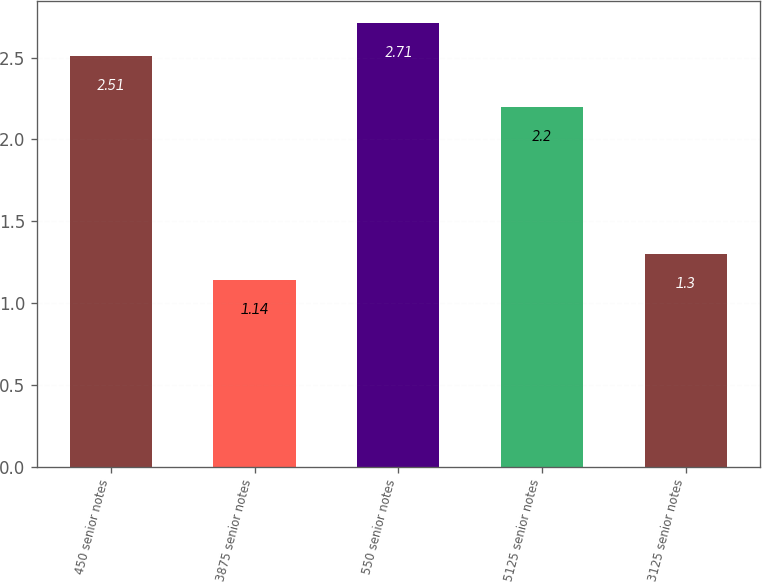Convert chart to OTSL. <chart><loc_0><loc_0><loc_500><loc_500><bar_chart><fcel>450 senior notes<fcel>3875 senior notes<fcel>550 senior notes<fcel>5125 senior notes<fcel>3125 senior notes<nl><fcel>2.51<fcel>1.14<fcel>2.71<fcel>2.2<fcel>1.3<nl></chart> 